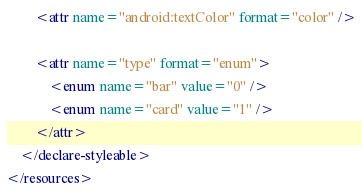<code> <loc_0><loc_0><loc_500><loc_500><_XML_>        <attr name="android:textColor" format="color" />

        <attr name="type" format="enum">
            <enum name="bar" value="0" />
            <enum name="card" value="1" />
        </attr>
    </declare-styleable>
</resources></code> 